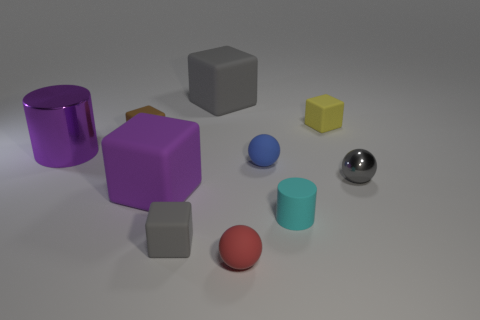Imagine these objects are meant to represent a family, can you tell me a story about them? In a dimension of shapes and shades, the Cylinder family lived harmoniously. Mr. Silver Cylinder was known for his brilliant ideas that reflected the family's values. Mrs. Purple Prism, the matriarch, stood tall with her uplifting spirit. Junior, the little blue sphere, and his tiny yellow companion, Baby Cube, played joyfully in the expanse of their geometric home, while Auntie Grey Cube watched over them with her trio of wisdom. The Red Spheroid, the pet of the family, always stayed close to the family, reflecting their warm love. Together, they created a world where angles met curves and polished surfaces danced with matte vistas—a tale of the Cylinder family living in unity within the realm of shapes. 